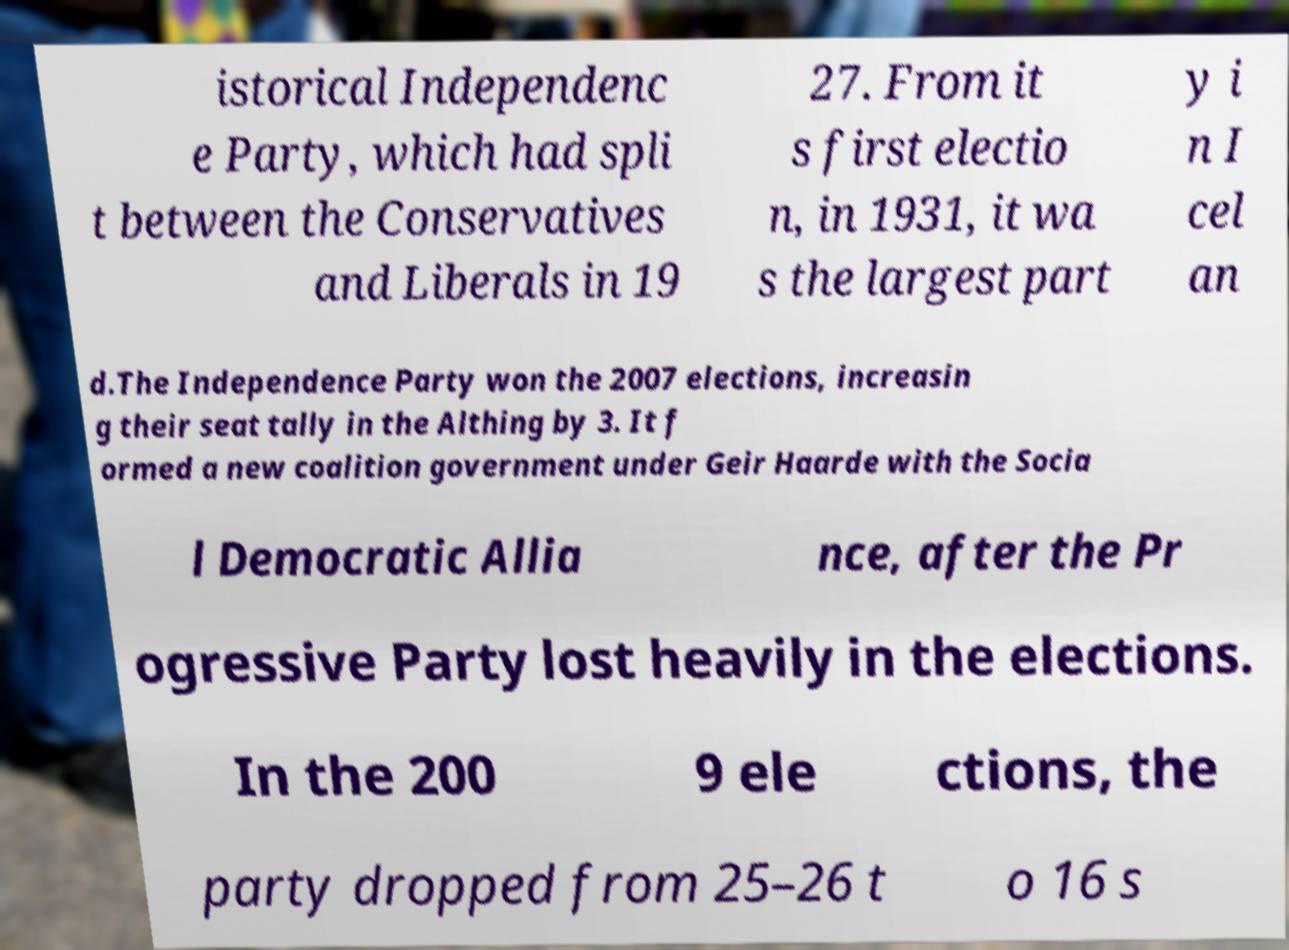Can you accurately transcribe the text from the provided image for me? istorical Independenc e Party, which had spli t between the Conservatives and Liberals in 19 27. From it s first electio n, in 1931, it wa s the largest part y i n I cel an d.The Independence Party won the 2007 elections, increasin g their seat tally in the Althing by 3. It f ormed a new coalition government under Geir Haarde with the Socia l Democratic Allia nce, after the Pr ogressive Party lost heavily in the elections. In the 200 9 ele ctions, the party dropped from 25–26 t o 16 s 